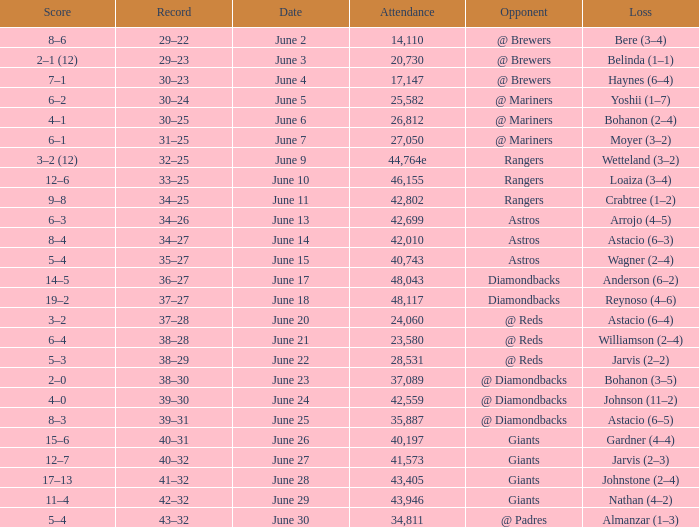Can you give me this table as a dict? {'header': ['Score', 'Record', 'Date', 'Attendance', 'Opponent', 'Loss'], 'rows': [['8–6', '29–22', 'June 2', '14,110', '@ Brewers', 'Bere (3–4)'], ['2–1 (12)', '29–23', 'June 3', '20,730', '@ Brewers', 'Belinda (1–1)'], ['7–1', '30–23', 'June 4', '17,147', '@ Brewers', 'Haynes (6–4)'], ['6–2', '30–24', 'June 5', '25,582', '@ Mariners', 'Yoshii (1–7)'], ['4–1', '30–25', 'June 6', '26,812', '@ Mariners', 'Bohanon (2–4)'], ['6–1', '31–25', 'June 7', '27,050', '@ Mariners', 'Moyer (3–2)'], ['3–2 (12)', '32–25', 'June 9', '44,764e', 'Rangers', 'Wetteland (3–2)'], ['12–6', '33–25', 'June 10', '46,155', 'Rangers', 'Loaiza (3–4)'], ['9–8', '34–25', 'June 11', '42,802', 'Rangers', 'Crabtree (1–2)'], ['6–3', '34–26', 'June 13', '42,699', 'Astros', 'Arrojo (4–5)'], ['8–4', '34–27', 'June 14', '42,010', 'Astros', 'Astacio (6–3)'], ['5–4', '35–27', 'June 15', '40,743', 'Astros', 'Wagner (2–4)'], ['14–5', '36–27', 'June 17', '48,043', 'Diamondbacks', 'Anderson (6–2)'], ['19–2', '37–27', 'June 18', '48,117', 'Diamondbacks', 'Reynoso (4–6)'], ['3–2', '37–28', 'June 20', '24,060', '@ Reds', 'Astacio (6–4)'], ['6–4', '38–28', 'June 21', '23,580', '@ Reds', 'Williamson (2–4)'], ['5–3', '38–29', 'June 22', '28,531', '@ Reds', 'Jarvis (2–2)'], ['2–0', '38–30', 'June 23', '37,089', '@ Diamondbacks', 'Bohanon (3–5)'], ['4–0', '39–30', 'June 24', '42,559', '@ Diamondbacks', 'Johnson (11–2)'], ['8–3', '39–31', 'June 25', '35,887', '@ Diamondbacks', 'Astacio (6–5)'], ['15–6', '40–31', 'June 26', '40,197', 'Giants', 'Gardner (4–4)'], ['12–7', '40–32', 'June 27', '41,573', 'Giants', 'Jarvis (2–3)'], ['17–13', '41–32', 'June 28', '43,405', 'Giants', 'Johnstone (2–4)'], ['11–4', '42–32', 'June 29', '43,946', 'Giants', 'Nathan (4–2)'], ['5–4', '43–32', 'June 30', '34,811', '@ Padres', 'Almanzar (1–3)']]} What's the record when the attendance was 28,531? 38–29. 